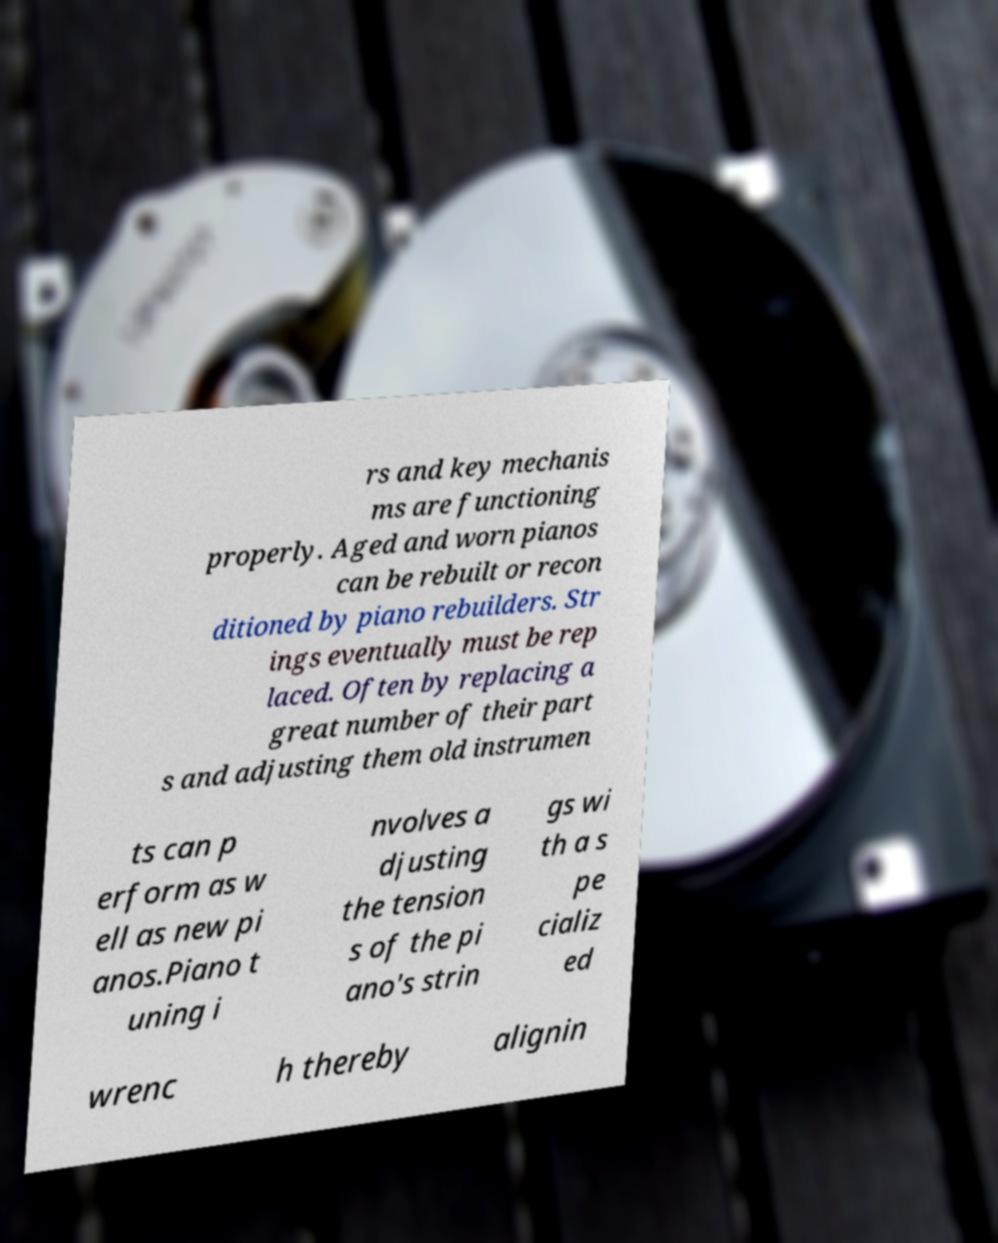Can you read and provide the text displayed in the image?This photo seems to have some interesting text. Can you extract and type it out for me? rs and key mechanis ms are functioning properly. Aged and worn pianos can be rebuilt or recon ditioned by piano rebuilders. Str ings eventually must be rep laced. Often by replacing a great number of their part s and adjusting them old instrumen ts can p erform as w ell as new pi anos.Piano t uning i nvolves a djusting the tension s of the pi ano's strin gs wi th a s pe cializ ed wrenc h thereby alignin 